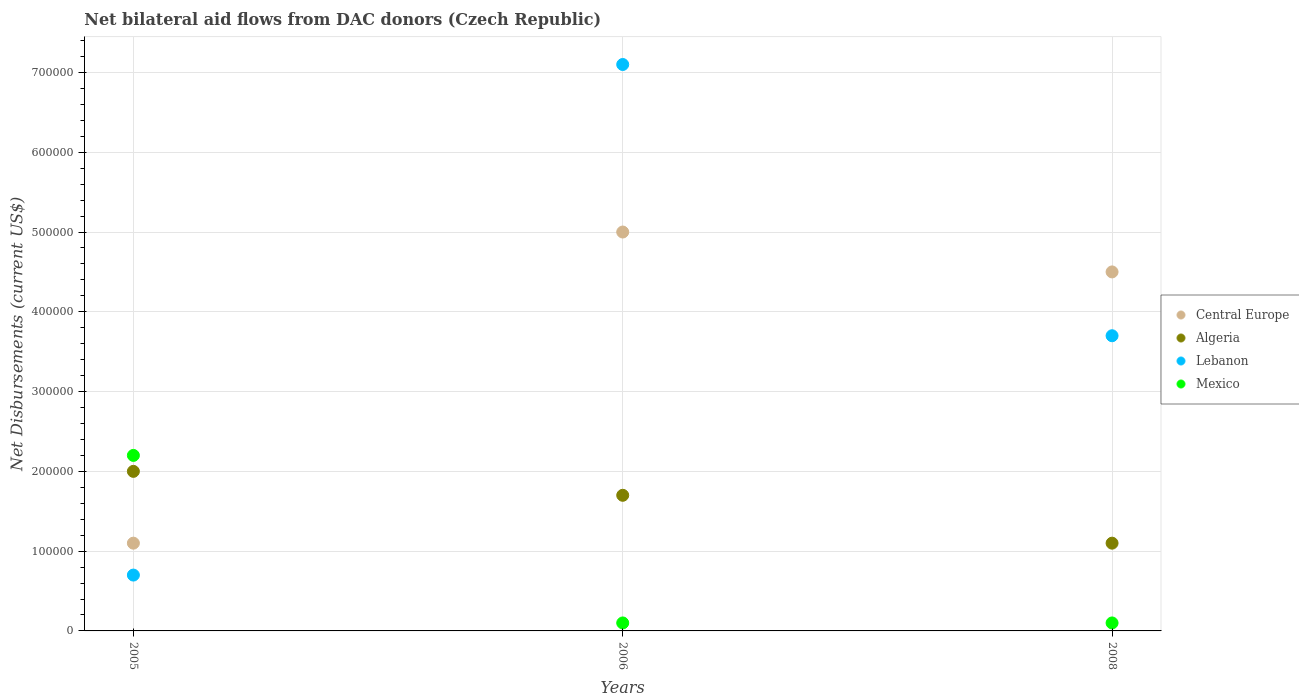How many different coloured dotlines are there?
Provide a succinct answer. 4. Is the number of dotlines equal to the number of legend labels?
Your answer should be very brief. Yes. What is the net bilateral aid flows in Lebanon in 2005?
Provide a succinct answer. 7.00e+04. Across all years, what is the minimum net bilateral aid flows in Lebanon?
Provide a succinct answer. 7.00e+04. In which year was the net bilateral aid flows in Mexico minimum?
Make the answer very short. 2006. What is the total net bilateral aid flows in Lebanon in the graph?
Your response must be concise. 1.15e+06. What is the difference between the net bilateral aid flows in Lebanon in 2005 and that in 2006?
Offer a terse response. -6.40e+05. What is the difference between the net bilateral aid flows in Lebanon in 2006 and the net bilateral aid flows in Mexico in 2008?
Give a very brief answer. 7.00e+05. In the year 2006, what is the difference between the net bilateral aid flows in Algeria and net bilateral aid flows in Central Europe?
Give a very brief answer. -3.30e+05. In how many years, is the net bilateral aid flows in Algeria greater than 540000 US$?
Ensure brevity in your answer.  0. What is the ratio of the net bilateral aid flows in Lebanon in 2005 to that in 2008?
Make the answer very short. 0.19. Is it the case that in every year, the sum of the net bilateral aid flows in Algeria and net bilateral aid flows in Mexico  is greater than the net bilateral aid flows in Central Europe?
Your answer should be compact. No. Does the net bilateral aid flows in Central Europe monotonically increase over the years?
Give a very brief answer. No. Is the net bilateral aid flows in Algeria strictly greater than the net bilateral aid flows in Central Europe over the years?
Provide a succinct answer. No. How many years are there in the graph?
Offer a very short reply. 3. What is the difference between two consecutive major ticks on the Y-axis?
Give a very brief answer. 1.00e+05. Does the graph contain any zero values?
Your answer should be compact. No. Where does the legend appear in the graph?
Your response must be concise. Center right. How are the legend labels stacked?
Give a very brief answer. Vertical. What is the title of the graph?
Your response must be concise. Net bilateral aid flows from DAC donors (Czech Republic). What is the label or title of the X-axis?
Offer a terse response. Years. What is the label or title of the Y-axis?
Offer a terse response. Net Disbursements (current US$). What is the Net Disbursements (current US$) of Central Europe in 2005?
Your answer should be compact. 1.10e+05. What is the Net Disbursements (current US$) in Lebanon in 2005?
Your answer should be compact. 7.00e+04. What is the Net Disbursements (current US$) in Central Europe in 2006?
Give a very brief answer. 5.00e+05. What is the Net Disbursements (current US$) of Algeria in 2006?
Keep it short and to the point. 1.70e+05. What is the Net Disbursements (current US$) of Lebanon in 2006?
Your response must be concise. 7.10e+05. What is the Net Disbursements (current US$) in Mexico in 2006?
Your response must be concise. 10000. What is the Net Disbursements (current US$) in Central Europe in 2008?
Ensure brevity in your answer.  4.50e+05. What is the Net Disbursements (current US$) in Algeria in 2008?
Your response must be concise. 1.10e+05. What is the Net Disbursements (current US$) in Lebanon in 2008?
Give a very brief answer. 3.70e+05. Across all years, what is the maximum Net Disbursements (current US$) of Central Europe?
Provide a succinct answer. 5.00e+05. Across all years, what is the maximum Net Disbursements (current US$) in Lebanon?
Make the answer very short. 7.10e+05. Across all years, what is the maximum Net Disbursements (current US$) of Mexico?
Provide a short and direct response. 2.20e+05. Across all years, what is the minimum Net Disbursements (current US$) in Central Europe?
Give a very brief answer. 1.10e+05. Across all years, what is the minimum Net Disbursements (current US$) of Algeria?
Keep it short and to the point. 1.10e+05. Across all years, what is the minimum Net Disbursements (current US$) in Lebanon?
Give a very brief answer. 7.00e+04. Across all years, what is the minimum Net Disbursements (current US$) of Mexico?
Ensure brevity in your answer.  10000. What is the total Net Disbursements (current US$) of Central Europe in the graph?
Give a very brief answer. 1.06e+06. What is the total Net Disbursements (current US$) in Lebanon in the graph?
Make the answer very short. 1.15e+06. What is the total Net Disbursements (current US$) in Mexico in the graph?
Ensure brevity in your answer.  2.40e+05. What is the difference between the Net Disbursements (current US$) in Central Europe in 2005 and that in 2006?
Provide a succinct answer. -3.90e+05. What is the difference between the Net Disbursements (current US$) of Algeria in 2005 and that in 2006?
Provide a short and direct response. 3.00e+04. What is the difference between the Net Disbursements (current US$) of Lebanon in 2005 and that in 2006?
Your answer should be very brief. -6.40e+05. What is the difference between the Net Disbursements (current US$) of Algeria in 2005 and that in 2008?
Your response must be concise. 9.00e+04. What is the difference between the Net Disbursements (current US$) of Mexico in 2006 and that in 2008?
Make the answer very short. 0. What is the difference between the Net Disbursements (current US$) of Central Europe in 2005 and the Net Disbursements (current US$) of Algeria in 2006?
Your answer should be compact. -6.00e+04. What is the difference between the Net Disbursements (current US$) of Central Europe in 2005 and the Net Disbursements (current US$) of Lebanon in 2006?
Your response must be concise. -6.00e+05. What is the difference between the Net Disbursements (current US$) in Algeria in 2005 and the Net Disbursements (current US$) in Lebanon in 2006?
Keep it short and to the point. -5.10e+05. What is the difference between the Net Disbursements (current US$) of Central Europe in 2005 and the Net Disbursements (current US$) of Lebanon in 2008?
Provide a succinct answer. -2.60e+05. What is the difference between the Net Disbursements (current US$) in Algeria in 2005 and the Net Disbursements (current US$) in Mexico in 2008?
Your answer should be very brief. 1.90e+05. What is the difference between the Net Disbursements (current US$) in Algeria in 2006 and the Net Disbursements (current US$) in Mexico in 2008?
Give a very brief answer. 1.60e+05. What is the average Net Disbursements (current US$) of Central Europe per year?
Your answer should be very brief. 3.53e+05. What is the average Net Disbursements (current US$) of Algeria per year?
Offer a very short reply. 1.60e+05. What is the average Net Disbursements (current US$) in Lebanon per year?
Offer a very short reply. 3.83e+05. What is the average Net Disbursements (current US$) in Mexico per year?
Offer a terse response. 8.00e+04. In the year 2005, what is the difference between the Net Disbursements (current US$) in Central Europe and Net Disbursements (current US$) in Lebanon?
Give a very brief answer. 4.00e+04. In the year 2005, what is the difference between the Net Disbursements (current US$) of Central Europe and Net Disbursements (current US$) of Mexico?
Offer a terse response. -1.10e+05. In the year 2005, what is the difference between the Net Disbursements (current US$) in Algeria and Net Disbursements (current US$) in Mexico?
Ensure brevity in your answer.  -2.00e+04. In the year 2006, what is the difference between the Net Disbursements (current US$) of Central Europe and Net Disbursements (current US$) of Algeria?
Make the answer very short. 3.30e+05. In the year 2006, what is the difference between the Net Disbursements (current US$) in Central Europe and Net Disbursements (current US$) in Mexico?
Make the answer very short. 4.90e+05. In the year 2006, what is the difference between the Net Disbursements (current US$) of Algeria and Net Disbursements (current US$) of Lebanon?
Provide a short and direct response. -5.40e+05. In the year 2006, what is the difference between the Net Disbursements (current US$) in Lebanon and Net Disbursements (current US$) in Mexico?
Offer a very short reply. 7.00e+05. In the year 2008, what is the difference between the Net Disbursements (current US$) of Central Europe and Net Disbursements (current US$) of Mexico?
Keep it short and to the point. 4.40e+05. In the year 2008, what is the difference between the Net Disbursements (current US$) of Lebanon and Net Disbursements (current US$) of Mexico?
Offer a terse response. 3.60e+05. What is the ratio of the Net Disbursements (current US$) of Central Europe in 2005 to that in 2006?
Keep it short and to the point. 0.22. What is the ratio of the Net Disbursements (current US$) of Algeria in 2005 to that in 2006?
Your response must be concise. 1.18. What is the ratio of the Net Disbursements (current US$) of Lebanon in 2005 to that in 2006?
Offer a very short reply. 0.1. What is the ratio of the Net Disbursements (current US$) in Central Europe in 2005 to that in 2008?
Provide a succinct answer. 0.24. What is the ratio of the Net Disbursements (current US$) in Algeria in 2005 to that in 2008?
Keep it short and to the point. 1.82. What is the ratio of the Net Disbursements (current US$) in Lebanon in 2005 to that in 2008?
Provide a short and direct response. 0.19. What is the ratio of the Net Disbursements (current US$) of Mexico in 2005 to that in 2008?
Your answer should be compact. 22. What is the ratio of the Net Disbursements (current US$) in Central Europe in 2006 to that in 2008?
Your response must be concise. 1.11. What is the ratio of the Net Disbursements (current US$) in Algeria in 2006 to that in 2008?
Your answer should be very brief. 1.55. What is the ratio of the Net Disbursements (current US$) in Lebanon in 2006 to that in 2008?
Your answer should be very brief. 1.92. What is the ratio of the Net Disbursements (current US$) in Mexico in 2006 to that in 2008?
Give a very brief answer. 1. What is the difference between the highest and the second highest Net Disbursements (current US$) in Algeria?
Provide a succinct answer. 3.00e+04. What is the difference between the highest and the lowest Net Disbursements (current US$) of Algeria?
Offer a terse response. 9.00e+04. What is the difference between the highest and the lowest Net Disbursements (current US$) in Lebanon?
Ensure brevity in your answer.  6.40e+05. What is the difference between the highest and the lowest Net Disbursements (current US$) in Mexico?
Your response must be concise. 2.10e+05. 